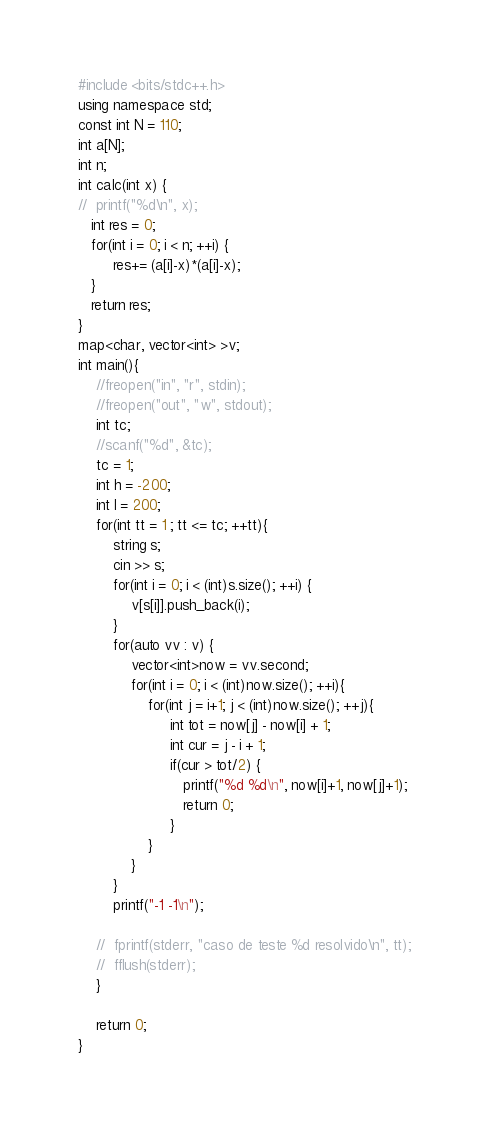Convert code to text. <code><loc_0><loc_0><loc_500><loc_500><_C++_>#include <bits/stdc++.h>
using namespace std;
const int N = 110;
int a[N];
int n;
int calc(int x) {
//	printf("%d\n", x);
   int res = 0;
   for(int i = 0; i < n; ++i) {
		res+= (a[i]-x)*(a[i]-x);
   }
   return res;
}
map<char, vector<int> >v;
int main(){
 	//freopen("in", "r", stdin);
  	//freopen("out", "w", stdout);
	int tc;
	//scanf("%d", &tc);
	tc = 1;
	int h = -200;
	int l = 200;
	for(int tt = 1 ; tt <= tc; ++tt){
		string s;
		cin >> s;
		for(int i = 0; i < (int)s.size(); ++i) {
		 	v[s[i]].push_back(i);
		}
		for(auto vv : v) {
			vector<int>now = vv.second;
			for(int i = 0; i < (int)now.size(); ++i){
			 	for(int j = i+1; j < (int)now.size(); ++j){
			 	     int tot = now[j] - now[i] + 1;
			 	     int cur = j - i + 1;
			 	     if(cur > tot/2) {
			 	      	printf("%d %d\n", now[i]+1, now[j]+1);
			 	      	return 0;
			 	     }
			 	}
			}
		}
		printf("-1 -1\n");
	  	
	//	fprintf(stderr, "caso de teste %d resolvido\n", tt);
	//	fflush(stderr);
	}
	
	return 0;
}</code> 